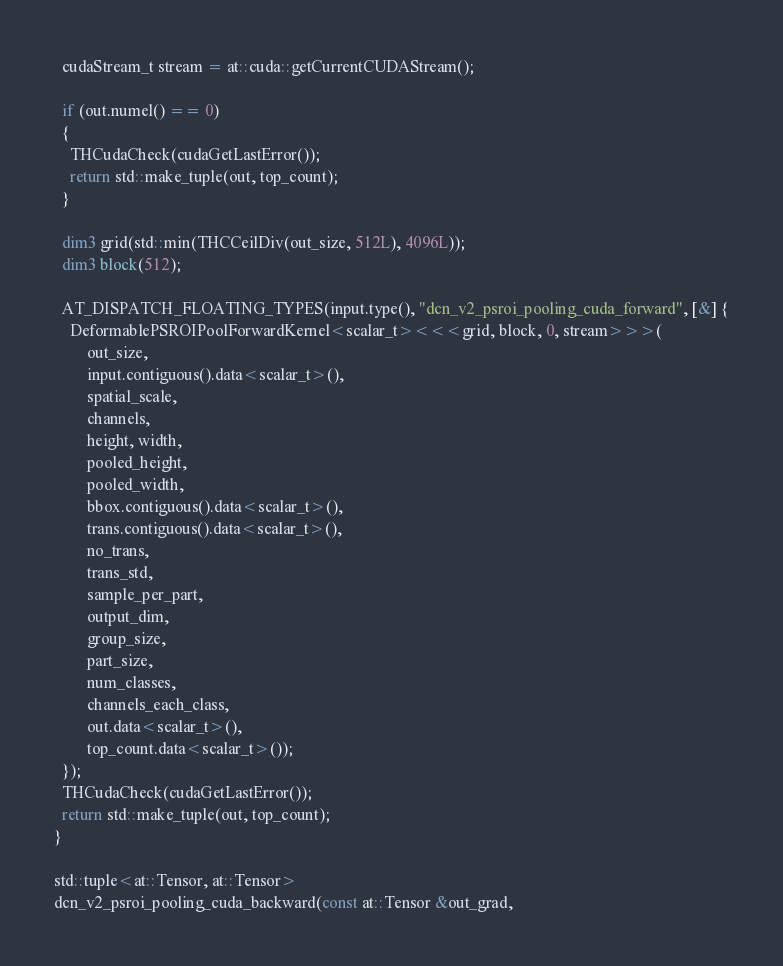Convert code to text. <code><loc_0><loc_0><loc_500><loc_500><_Cuda_>
  cudaStream_t stream = at::cuda::getCurrentCUDAStream();

  if (out.numel() == 0)
  {
    THCudaCheck(cudaGetLastError());
    return std::make_tuple(out, top_count);
  }

  dim3 grid(std::min(THCCeilDiv(out_size, 512L), 4096L));
  dim3 block(512);

  AT_DISPATCH_FLOATING_TYPES(input.type(), "dcn_v2_psroi_pooling_cuda_forward", [&] {
    DeformablePSROIPoolForwardKernel<scalar_t><<<grid, block, 0, stream>>>(
        out_size,
        input.contiguous().data<scalar_t>(),
        spatial_scale,
        channels,
        height, width,
        pooled_height,
        pooled_width,
        bbox.contiguous().data<scalar_t>(),
        trans.contiguous().data<scalar_t>(),
        no_trans,
        trans_std,
        sample_per_part,
        output_dim,
        group_size,
        part_size,
        num_classes,
        channels_each_class,
        out.data<scalar_t>(),
        top_count.data<scalar_t>());
  });
  THCudaCheck(cudaGetLastError());
  return std::make_tuple(out, top_count);
}

std::tuple<at::Tensor, at::Tensor>
dcn_v2_psroi_pooling_cuda_backward(const at::Tensor &out_grad,</code> 